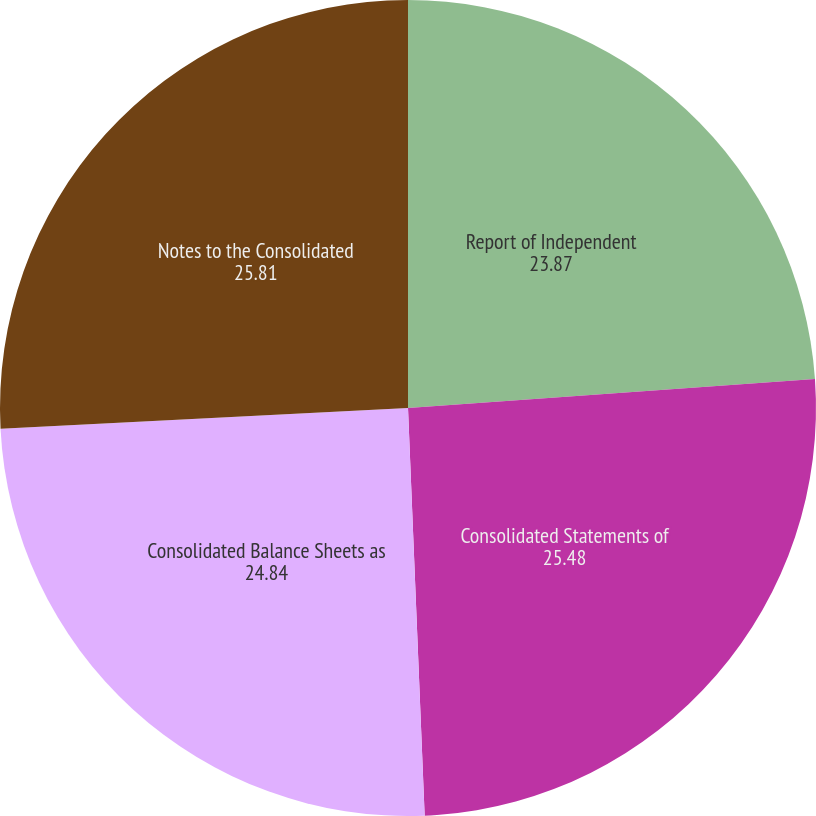Convert chart. <chart><loc_0><loc_0><loc_500><loc_500><pie_chart><fcel>Report of Independent<fcel>Consolidated Statements of<fcel>Consolidated Balance Sheets as<fcel>Notes to the Consolidated<nl><fcel>23.87%<fcel>25.48%<fcel>24.84%<fcel>25.81%<nl></chart> 